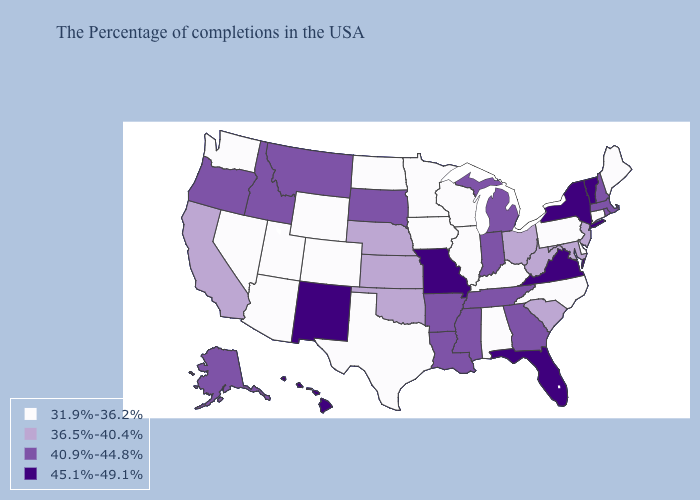Name the states that have a value in the range 40.9%-44.8%?
Quick response, please. Massachusetts, Rhode Island, New Hampshire, Georgia, Michigan, Indiana, Tennessee, Mississippi, Louisiana, Arkansas, South Dakota, Montana, Idaho, Oregon, Alaska. Which states hav the highest value in the West?
Write a very short answer. New Mexico, Hawaii. Does Vermont have the highest value in the Northeast?
Be succinct. Yes. Does North Carolina have the lowest value in the USA?
Short answer required. Yes. Does Kansas have the lowest value in the MidWest?
Give a very brief answer. No. Does Florida have the highest value in the USA?
Answer briefly. Yes. Among the states that border West Virginia , does Ohio have the highest value?
Quick response, please. No. Name the states that have a value in the range 36.5%-40.4%?
Concise answer only. New Jersey, Maryland, South Carolina, West Virginia, Ohio, Kansas, Nebraska, Oklahoma, California. Which states hav the highest value in the West?
Be succinct. New Mexico, Hawaii. What is the value of Nebraska?
Concise answer only. 36.5%-40.4%. Name the states that have a value in the range 31.9%-36.2%?
Keep it brief. Maine, Connecticut, Delaware, Pennsylvania, North Carolina, Kentucky, Alabama, Wisconsin, Illinois, Minnesota, Iowa, Texas, North Dakota, Wyoming, Colorado, Utah, Arizona, Nevada, Washington. Among the states that border Illinois , which have the lowest value?
Quick response, please. Kentucky, Wisconsin, Iowa. Which states have the lowest value in the West?
Short answer required. Wyoming, Colorado, Utah, Arizona, Nevada, Washington. Does New York have the highest value in the Northeast?
Answer briefly. Yes. What is the value of Connecticut?
Concise answer only. 31.9%-36.2%. 